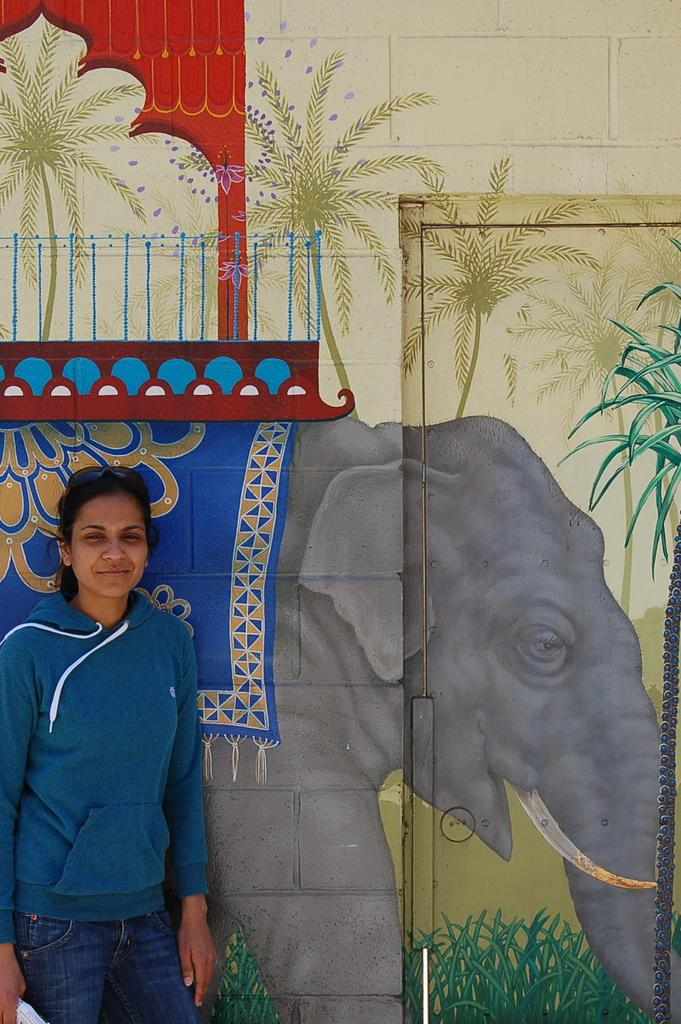Who is present on the left side of the image? There is a woman standing on the left side of the image. What can be seen in the background of the image? There is a wall in the image. What is depicted on the wall? There is an elephant painting on the wall. What type of food is being served in the lunchroom in the image? There is no lunchroom present in the image. Can you tell me the name of the person who gave birth to the elephant in the painting? The image does not depict a real elephant or its birth; it is a painting of an elephant on a wall. 